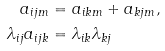Convert formula to latex. <formula><loc_0><loc_0><loc_500><loc_500>a _ { i j m } & = a _ { i k m } + a _ { k j m } , \\ \lambda _ { i j } a _ { i j k } & = \lambda _ { i k } \lambda _ { k j }</formula> 